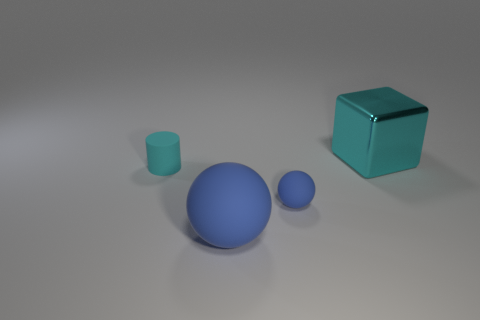What size is the cyan thing that is left of the tiny sphere?
Offer a terse response. Small. What shape is the thing that is both right of the tiny cylinder and behind the small blue matte thing?
Offer a very short reply. Cube. There is another matte thing that is the same shape as the big blue object; what is its size?
Provide a succinct answer. Small. What number of cyan cubes have the same material as the big blue thing?
Provide a succinct answer. 0. Do the big metallic thing and the large thing in front of the cyan shiny thing have the same color?
Your response must be concise. No. Is the number of large cyan things greater than the number of tiny blue blocks?
Your answer should be very brief. Yes. What color is the big rubber ball?
Your answer should be very brief. Blue. There is a big metallic block that is on the right side of the small cyan cylinder; does it have the same color as the cylinder?
Your answer should be very brief. Yes. There is another object that is the same color as the shiny thing; what material is it?
Offer a terse response. Rubber. What number of matte balls are the same color as the rubber cylinder?
Your response must be concise. 0. 